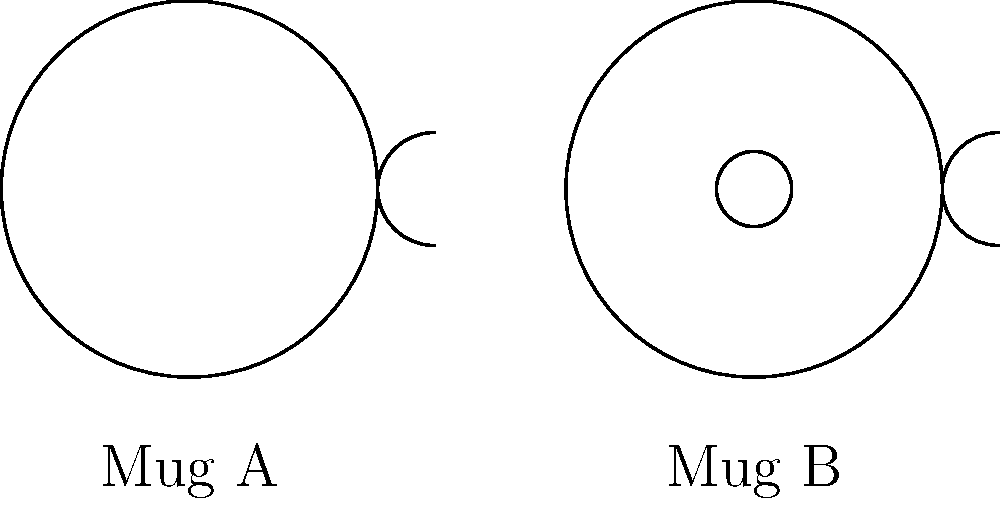You're helping your friend design cool coffee mugs for a local café in Reykjavík. Looking at the two mug designs above, which one would be more challenging to paint without leaving any unpainted spots? Why? Let's break this down step-by-step:

1. First, we need to understand what makes these mugs different topologically:
   - Mug A has one hole (the handle)
   - Mug B has two holes (the handle and the hole in the base)

2. In topology, the number of holes in an object is crucial. Objects with the same number of holes are considered topologically equivalent.

3. The number of holes affects how we can continuously deform the surface without tearing or gluing:
   - Mug A can be deformed into a donut (torus) shape
   - Mug B can be deformed into a shape similar to a donut with an extra hole

4. When painting, each hole creates an additional challenge:
   - You need to ensure paint coverage around and inside each hole
   - More holes mean more edges and corners to navigate

5. Therefore, Mug B would be more challenging to paint completely because:
   - It has more holes (2 vs 1)
   - It has more edges and corners to work around
   - It requires more careful maneuvering to ensure all surfaces are covered

In topological terms, Mug B has a higher genus (number of holes) than Mug A, making it more complex.
Answer: Mug B, due to its higher number of holes (genus). 